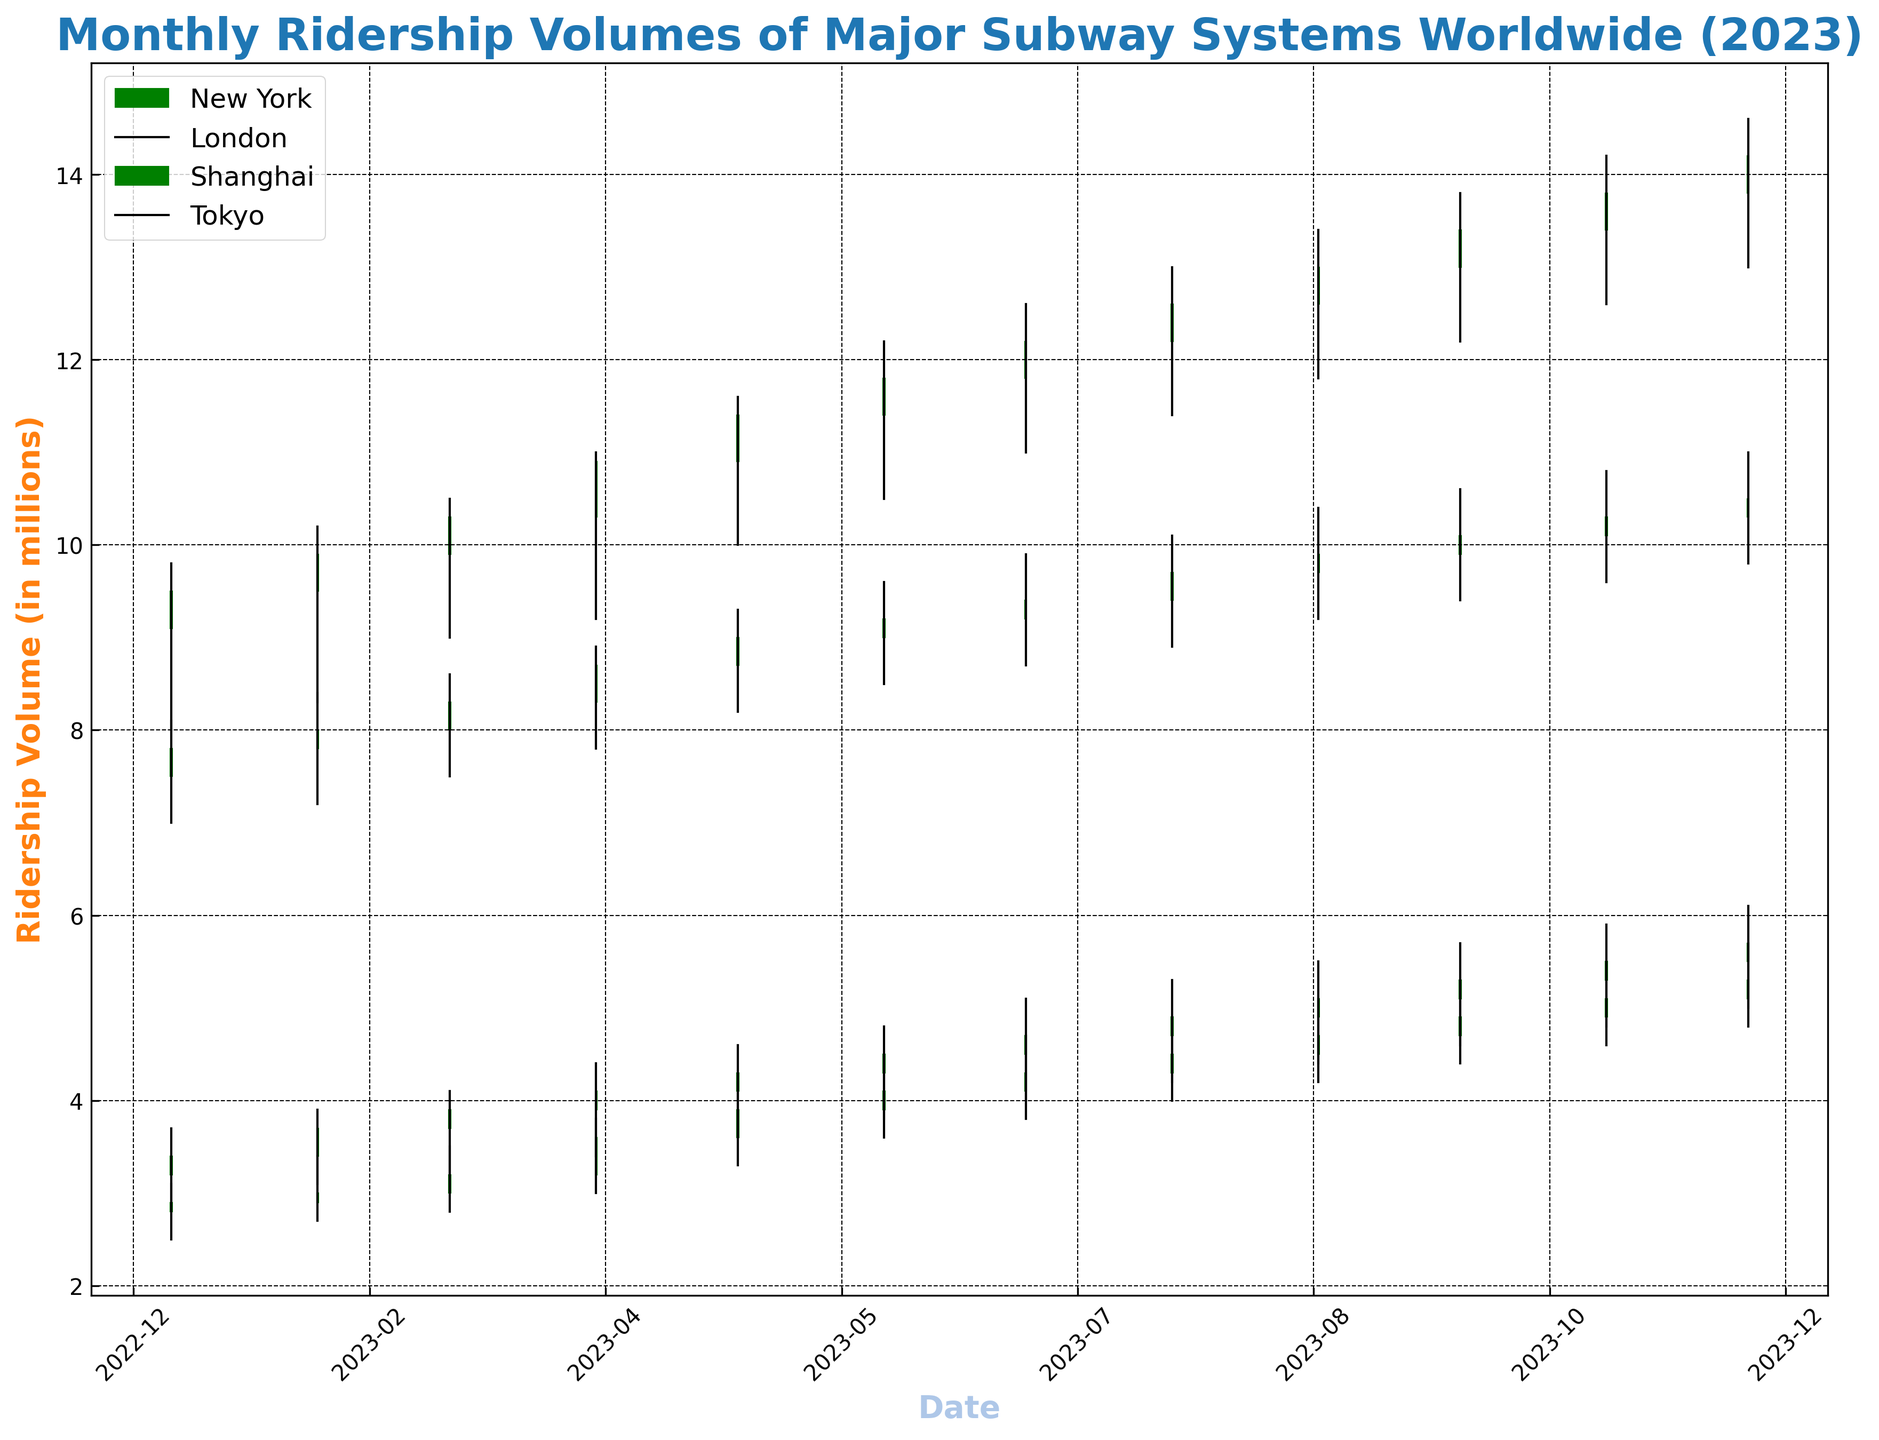What was the highest daily ridership volume for New York in 2023? To find the highest daily ridership volume for New York, look for the peak value in the "High" column for the New York entries. In the figure, this volume is marked as the highest point of the green or red bars representing New York.
Answer: 6.1 Which city had the highest increase in ridership volume from January to December 2023? Calculate the difference between the "Close" value in December and the "Open" value in January for each city. The city with the largest increase is the one with the highest positive difference.
Answer: Shanghai Which city's ridership volume remained below 5 million until June 2023? Review the "Close" values for each city for the months from January to June. Identify if any city's "Close" values remain consistently below 5 million until June.
Answer: London Compare the ridership volumes between Tokyo and New York in March 2023. Which city had higher daily lows? Look at the "Low" values for Tokyo and New York in March 2023. Compare the figures directly.
Answer: Tokyo On average, how much did Shanghai's ridership volume increase each month from January to December 2023? Calculate the monthly increase by taking the difference between sequential "Close" values for each month. Then, find the average by summing these differences and dividing by the number of months. ( (9.5-9.1)+(9.9-9.5)+(10.3-9.9)+...+(14.2-13.8) ) / 11
Answer: 0.473 million Which city had the most consistent ridership volume growth throughout the year? Consistency in growth can be interpreted as small and steady increments without significant drops. Examine the month-over-month differences in "Close" values for each city and identify which city has the most regular increments.
Answer: Tokyo How many months did New York's ridership volume end higher than it started in 2023? Count the months in which New York's "Close" value is higher than its "Open" value sequentially from January to December 2023.
Answer: 12 months Which city had the largest single-month increase in ridership volume in 2023? To find the largest single-month increase, look at the difference between "Close" and "Open" values within each month for each city. Identify the city and the month with the maximum positive difference.
Answer: Shanghai in September 